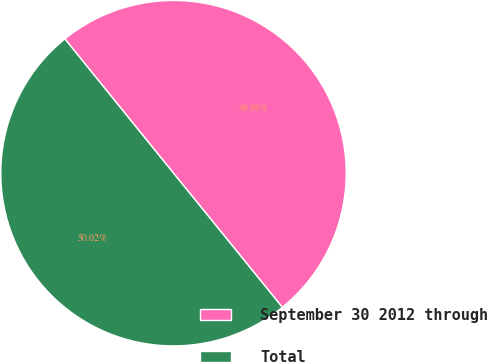Convert chart. <chart><loc_0><loc_0><loc_500><loc_500><pie_chart><fcel>September 30 2012 through<fcel>Total<nl><fcel>49.98%<fcel>50.02%<nl></chart> 